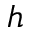<formula> <loc_0><loc_0><loc_500><loc_500>h</formula> 